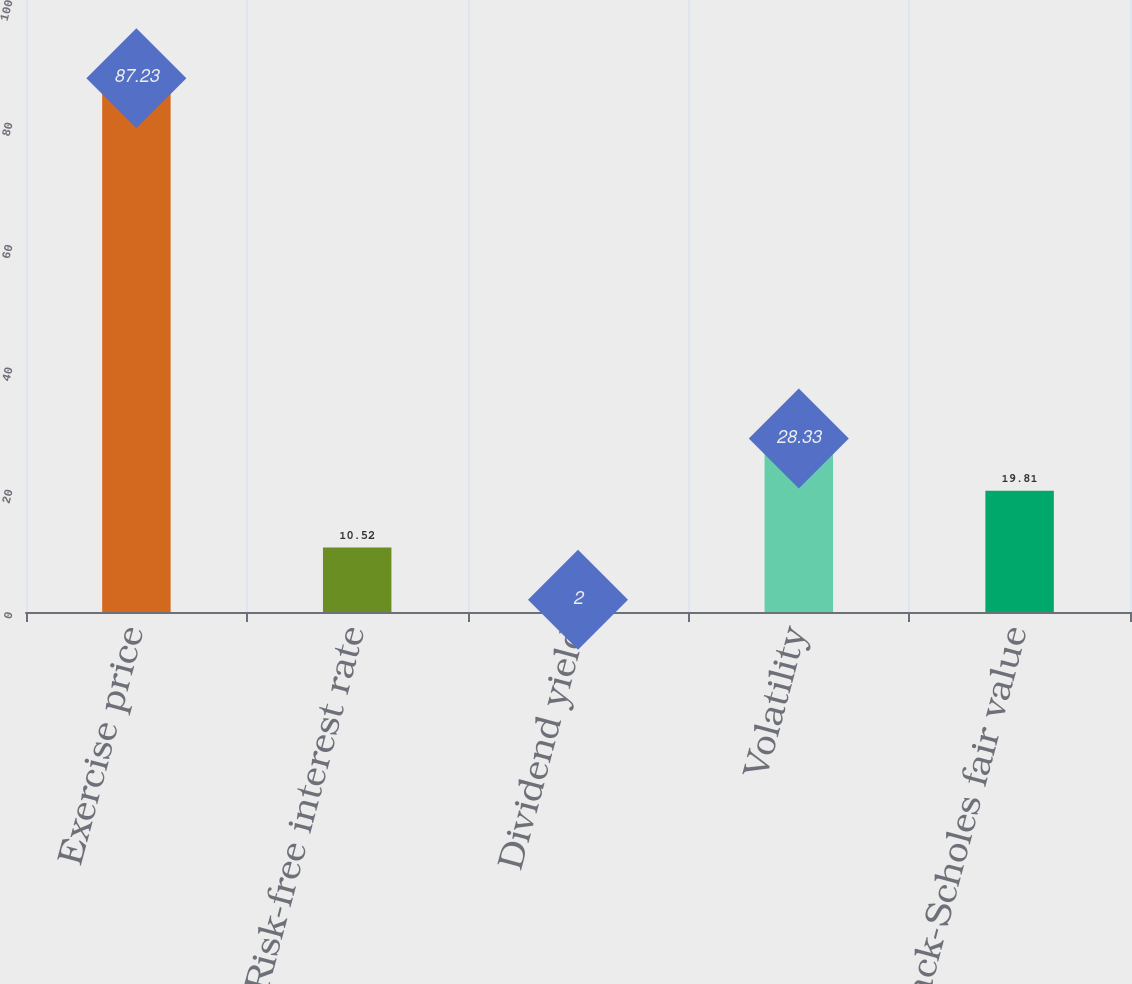Convert chart to OTSL. <chart><loc_0><loc_0><loc_500><loc_500><bar_chart><fcel>Exercise price<fcel>Risk-free interest rate<fcel>Dividend yield<fcel>Volatility<fcel>Black-Scholes fair value<nl><fcel>87.23<fcel>10.52<fcel>2<fcel>28.33<fcel>19.81<nl></chart> 